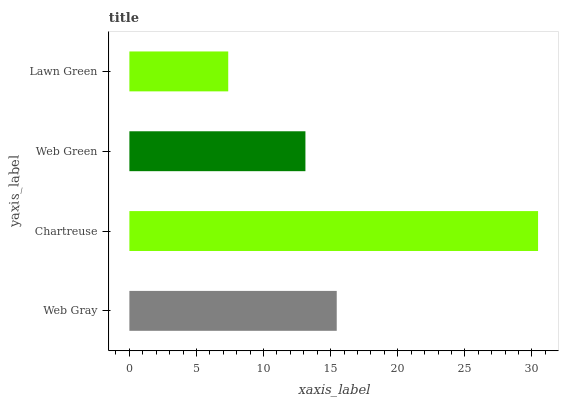Is Lawn Green the minimum?
Answer yes or no. Yes. Is Chartreuse the maximum?
Answer yes or no. Yes. Is Web Green the minimum?
Answer yes or no. No. Is Web Green the maximum?
Answer yes or no. No. Is Chartreuse greater than Web Green?
Answer yes or no. Yes. Is Web Green less than Chartreuse?
Answer yes or no. Yes. Is Web Green greater than Chartreuse?
Answer yes or no. No. Is Chartreuse less than Web Green?
Answer yes or no. No. Is Web Gray the high median?
Answer yes or no. Yes. Is Web Green the low median?
Answer yes or no. Yes. Is Chartreuse the high median?
Answer yes or no. No. Is Chartreuse the low median?
Answer yes or no. No. 